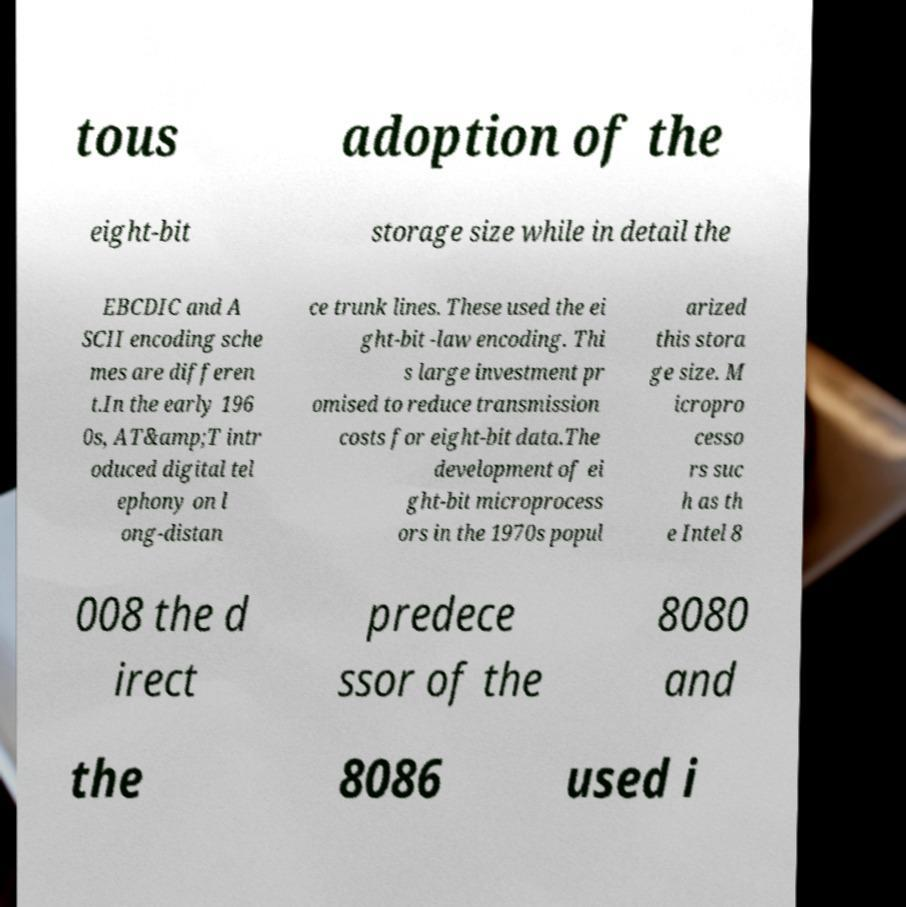Could you assist in decoding the text presented in this image and type it out clearly? tous adoption of the eight-bit storage size while in detail the EBCDIC and A SCII encoding sche mes are differen t.In the early 196 0s, AT&amp;T intr oduced digital tel ephony on l ong-distan ce trunk lines. These used the ei ght-bit -law encoding. Thi s large investment pr omised to reduce transmission costs for eight-bit data.The development of ei ght-bit microprocess ors in the 1970s popul arized this stora ge size. M icropro cesso rs suc h as th e Intel 8 008 the d irect predece ssor of the 8080 and the 8086 used i 